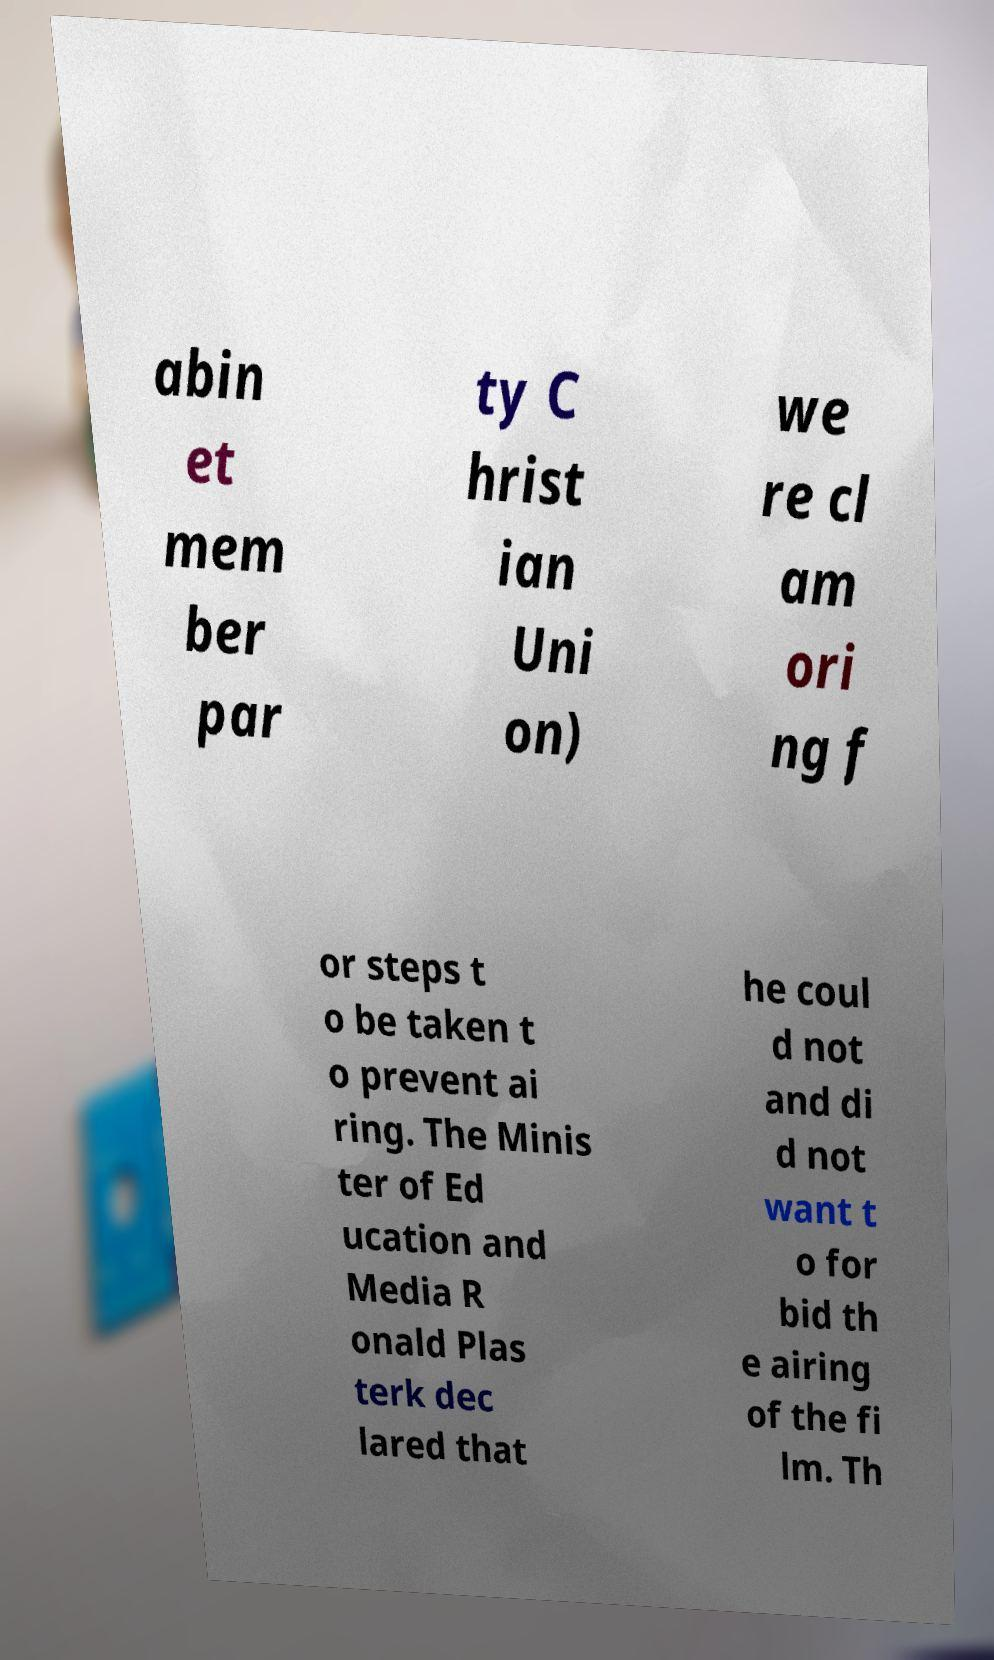There's text embedded in this image that I need extracted. Can you transcribe it verbatim? abin et mem ber par ty C hrist ian Uni on) we re cl am ori ng f or steps t o be taken t o prevent ai ring. The Minis ter of Ed ucation and Media R onald Plas terk dec lared that he coul d not and di d not want t o for bid th e airing of the fi lm. Th 